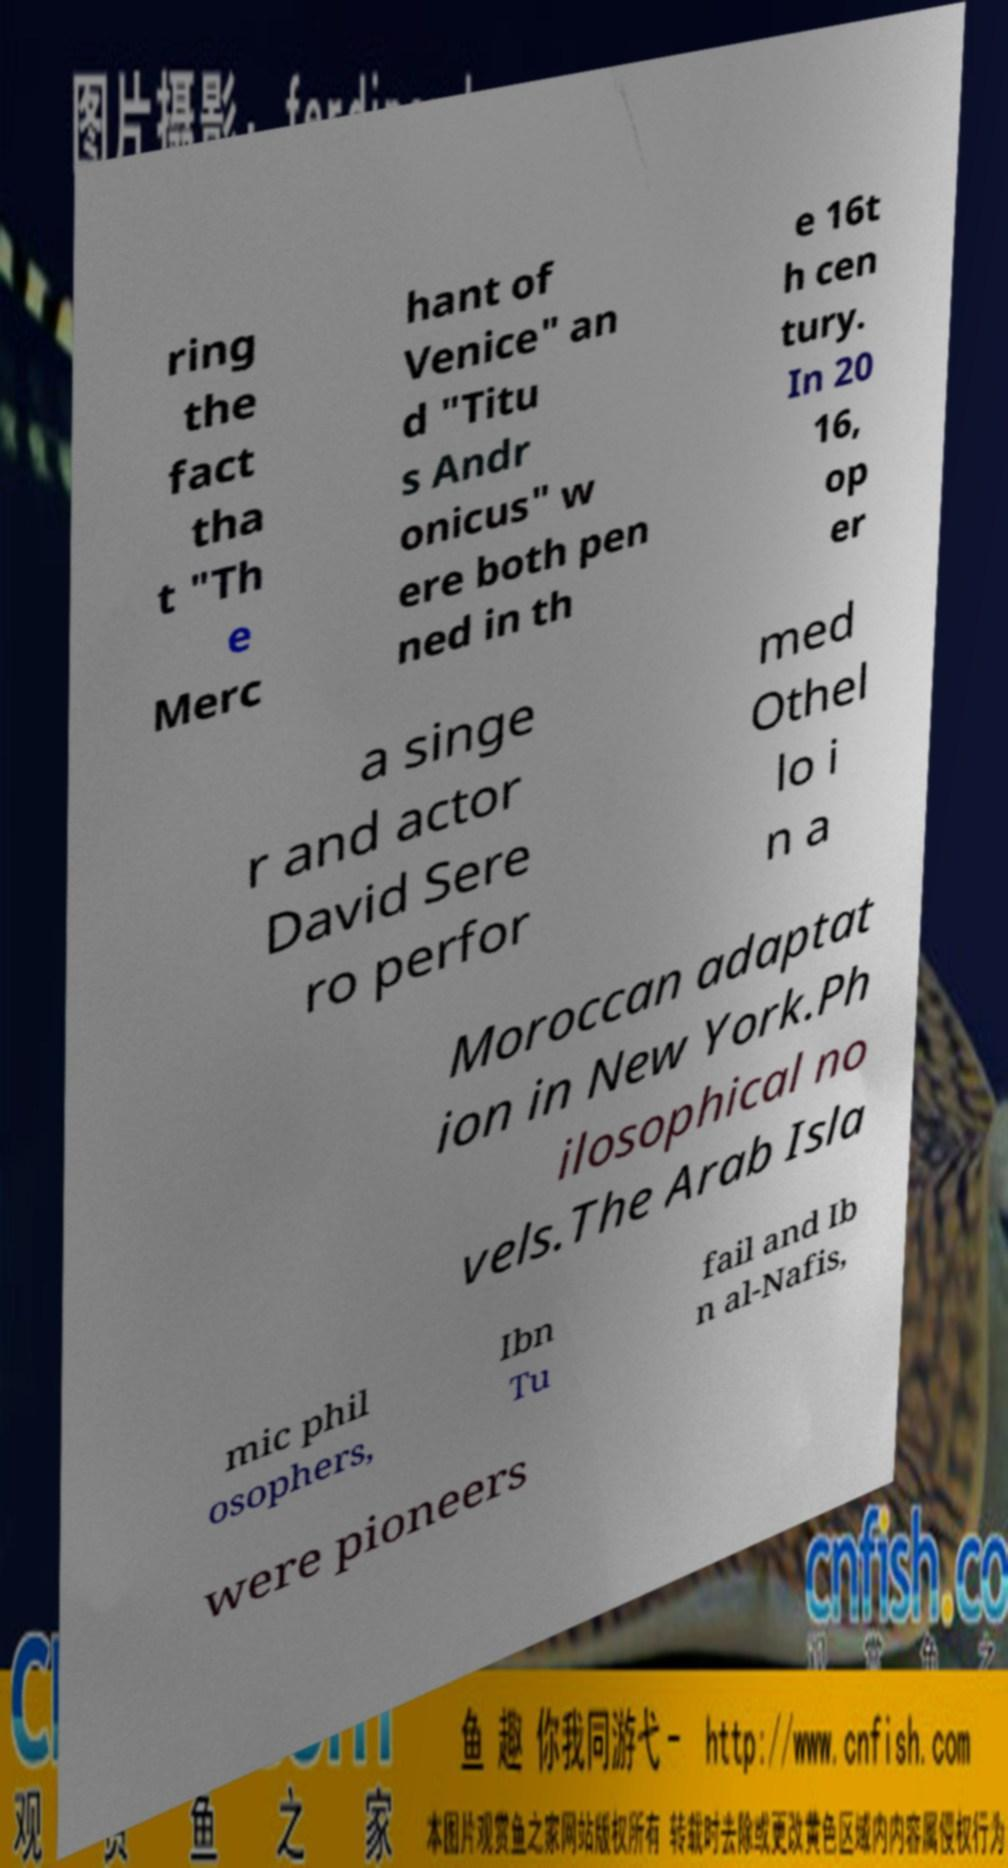There's text embedded in this image that I need extracted. Can you transcribe it verbatim? ring the fact tha t "Th e Merc hant of Venice" an d "Titu s Andr onicus" w ere both pen ned in th e 16t h cen tury. In 20 16, op er a singe r and actor David Sere ro perfor med Othel lo i n a Moroccan adaptat ion in New York.Ph ilosophical no vels.The Arab Isla mic phil osophers, Ibn Tu fail and Ib n al-Nafis, were pioneers 